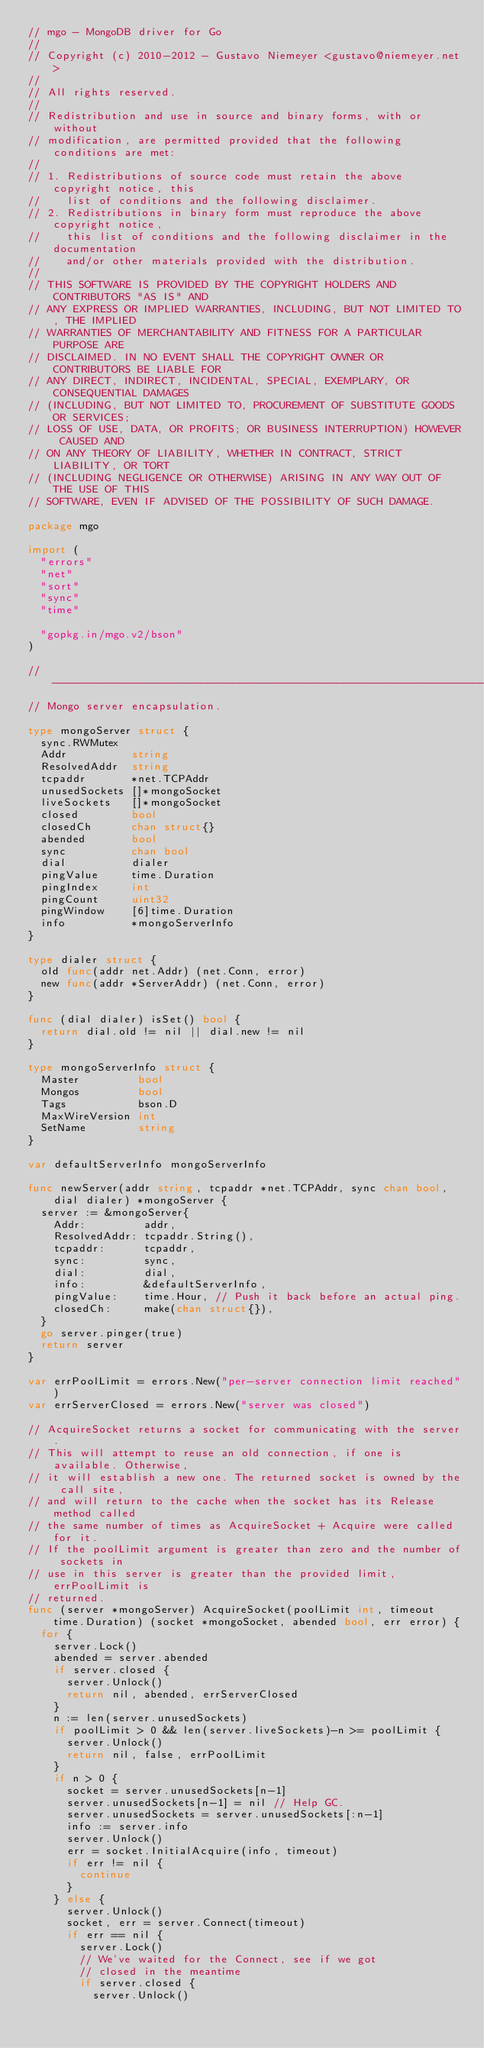Convert code to text. <code><loc_0><loc_0><loc_500><loc_500><_Go_>// mgo - MongoDB driver for Go
//
// Copyright (c) 2010-2012 - Gustavo Niemeyer <gustavo@niemeyer.net>
//
// All rights reserved.
//
// Redistribution and use in source and binary forms, with or without
// modification, are permitted provided that the following conditions are met:
//
// 1. Redistributions of source code must retain the above copyright notice, this
//    list of conditions and the following disclaimer.
// 2. Redistributions in binary form must reproduce the above copyright notice,
//    this list of conditions and the following disclaimer in the documentation
//    and/or other materials provided with the distribution.
//
// THIS SOFTWARE IS PROVIDED BY THE COPYRIGHT HOLDERS AND CONTRIBUTORS "AS IS" AND
// ANY EXPRESS OR IMPLIED WARRANTIES, INCLUDING, BUT NOT LIMITED TO, THE IMPLIED
// WARRANTIES OF MERCHANTABILITY AND FITNESS FOR A PARTICULAR PURPOSE ARE
// DISCLAIMED. IN NO EVENT SHALL THE COPYRIGHT OWNER OR CONTRIBUTORS BE LIABLE FOR
// ANY DIRECT, INDIRECT, INCIDENTAL, SPECIAL, EXEMPLARY, OR CONSEQUENTIAL DAMAGES
// (INCLUDING, BUT NOT LIMITED TO, PROCUREMENT OF SUBSTITUTE GOODS OR SERVICES;
// LOSS OF USE, DATA, OR PROFITS; OR BUSINESS INTERRUPTION) HOWEVER CAUSED AND
// ON ANY THEORY OF LIABILITY, WHETHER IN CONTRACT, STRICT LIABILITY, OR TORT
// (INCLUDING NEGLIGENCE OR OTHERWISE) ARISING IN ANY WAY OUT OF THE USE OF THIS
// SOFTWARE, EVEN IF ADVISED OF THE POSSIBILITY OF SUCH DAMAGE.

package mgo

import (
	"errors"
	"net"
	"sort"
	"sync"
	"time"

	"gopkg.in/mgo.v2/bson"
)

// ---------------------------------------------------------------------------
// Mongo server encapsulation.

type mongoServer struct {
	sync.RWMutex
	Addr          string
	ResolvedAddr  string
	tcpaddr       *net.TCPAddr
	unusedSockets []*mongoSocket
	liveSockets   []*mongoSocket
	closed        bool
	closedCh      chan struct{}
	abended       bool
	sync          chan bool
	dial          dialer
	pingValue     time.Duration
	pingIndex     int
	pingCount     uint32
	pingWindow    [6]time.Duration
	info          *mongoServerInfo
}

type dialer struct {
	old func(addr net.Addr) (net.Conn, error)
	new func(addr *ServerAddr) (net.Conn, error)
}

func (dial dialer) isSet() bool {
	return dial.old != nil || dial.new != nil
}

type mongoServerInfo struct {
	Master         bool
	Mongos         bool
	Tags           bson.D
	MaxWireVersion int
	SetName        string
}

var defaultServerInfo mongoServerInfo

func newServer(addr string, tcpaddr *net.TCPAddr, sync chan bool, dial dialer) *mongoServer {
	server := &mongoServer{
		Addr:         addr,
		ResolvedAddr: tcpaddr.String(),
		tcpaddr:      tcpaddr,
		sync:         sync,
		dial:         dial,
		info:         &defaultServerInfo,
		pingValue:    time.Hour, // Push it back before an actual ping.
		closedCh:     make(chan struct{}),
	}
	go server.pinger(true)
	return server
}

var errPoolLimit = errors.New("per-server connection limit reached")
var errServerClosed = errors.New("server was closed")

// AcquireSocket returns a socket for communicating with the server.
// This will attempt to reuse an old connection, if one is available. Otherwise,
// it will establish a new one. The returned socket is owned by the call site,
// and will return to the cache when the socket has its Release method called
// the same number of times as AcquireSocket + Acquire were called for it.
// If the poolLimit argument is greater than zero and the number of sockets in
// use in this server is greater than the provided limit, errPoolLimit is
// returned.
func (server *mongoServer) AcquireSocket(poolLimit int, timeout time.Duration) (socket *mongoSocket, abended bool, err error) {
	for {
		server.Lock()
		abended = server.abended
		if server.closed {
			server.Unlock()
			return nil, abended, errServerClosed
		}
		n := len(server.unusedSockets)
		if poolLimit > 0 && len(server.liveSockets)-n >= poolLimit {
			server.Unlock()
			return nil, false, errPoolLimit
		}
		if n > 0 {
			socket = server.unusedSockets[n-1]
			server.unusedSockets[n-1] = nil // Help GC.
			server.unusedSockets = server.unusedSockets[:n-1]
			info := server.info
			server.Unlock()
			err = socket.InitialAcquire(info, timeout)
			if err != nil {
				continue
			}
		} else {
			server.Unlock()
			socket, err = server.Connect(timeout)
			if err == nil {
				server.Lock()
				// We've waited for the Connect, see if we got
				// closed in the meantime
				if server.closed {
					server.Unlock()</code> 